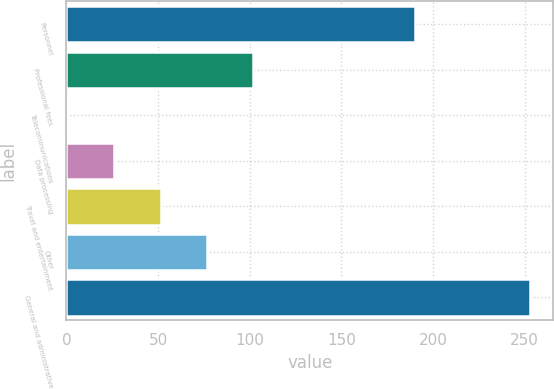Convert chart to OTSL. <chart><loc_0><loc_0><loc_500><loc_500><bar_chart><fcel>Personnel<fcel>Professional fees<fcel>Telecommunications<fcel>Data processing<fcel>Travel and entertainment<fcel>Other<fcel>General and administrative<nl><fcel>190<fcel>101.8<fcel>1<fcel>26.2<fcel>51.4<fcel>76.6<fcel>253<nl></chart> 